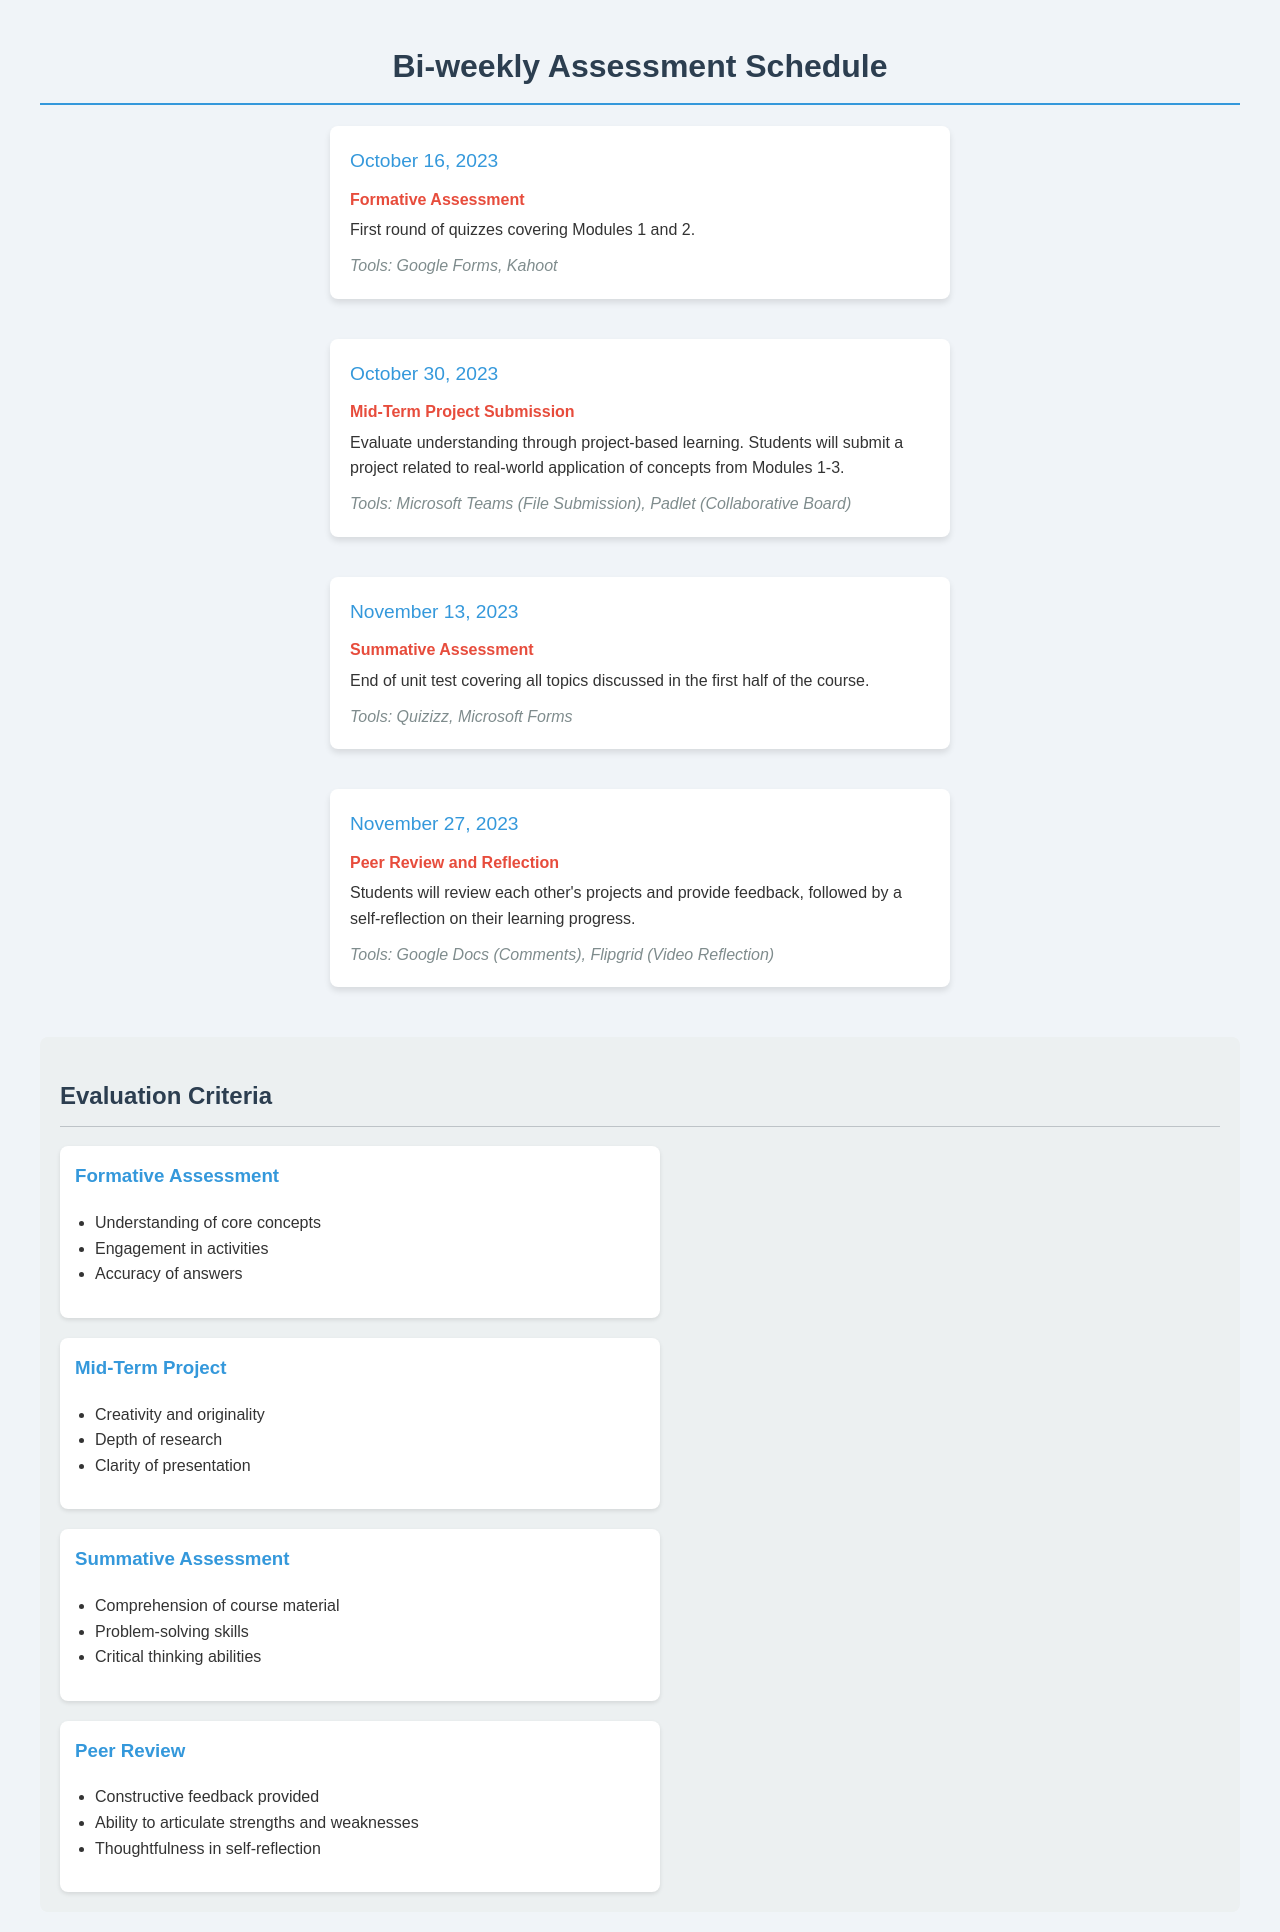What date is the first formative assessment? The first formative assessment is scheduled for October 16, 2023.
Answer: October 16, 2023 What tools will be used for the summative assessment? The tools identified for the summative assessment are Quizizz and Microsoft Forms.
Answer: Quizizz, Microsoft Forms What type of assessment is due on October 30, 2023? The assessment due on that date is a Mid-Term Project Submission.
Answer: Mid-Term Project Submission How many criteria are listed for the Peer Review assessment? There are three criteria outlined for the Peer Review assessment.
Answer: Three What will students submit for the Mid-Term Project? Students will submit a project related to the real-world application of concepts from Modules 1-3.
Answer: A project related to real-world application of concepts from Modules 1-3 What is the purpose of the Peer Review and Reflection assessment? The purpose is to have students review each other's projects and provide feedback, followed by self-reflection on their progress.
Answer: Review projects and provide feedback, self-reflection Which assessment covers all topics discussed in the first half of the course? The summative assessment covers all topics discussed in the first half of the course.
Answer: Summative Assessment What is the evaluation focus for the Mid-Term Project? The evaluation focuses on creativity and originality, depth of research, and clarity of presentation.
Answer: Creativity and originality, depth of research, clarity of presentation 